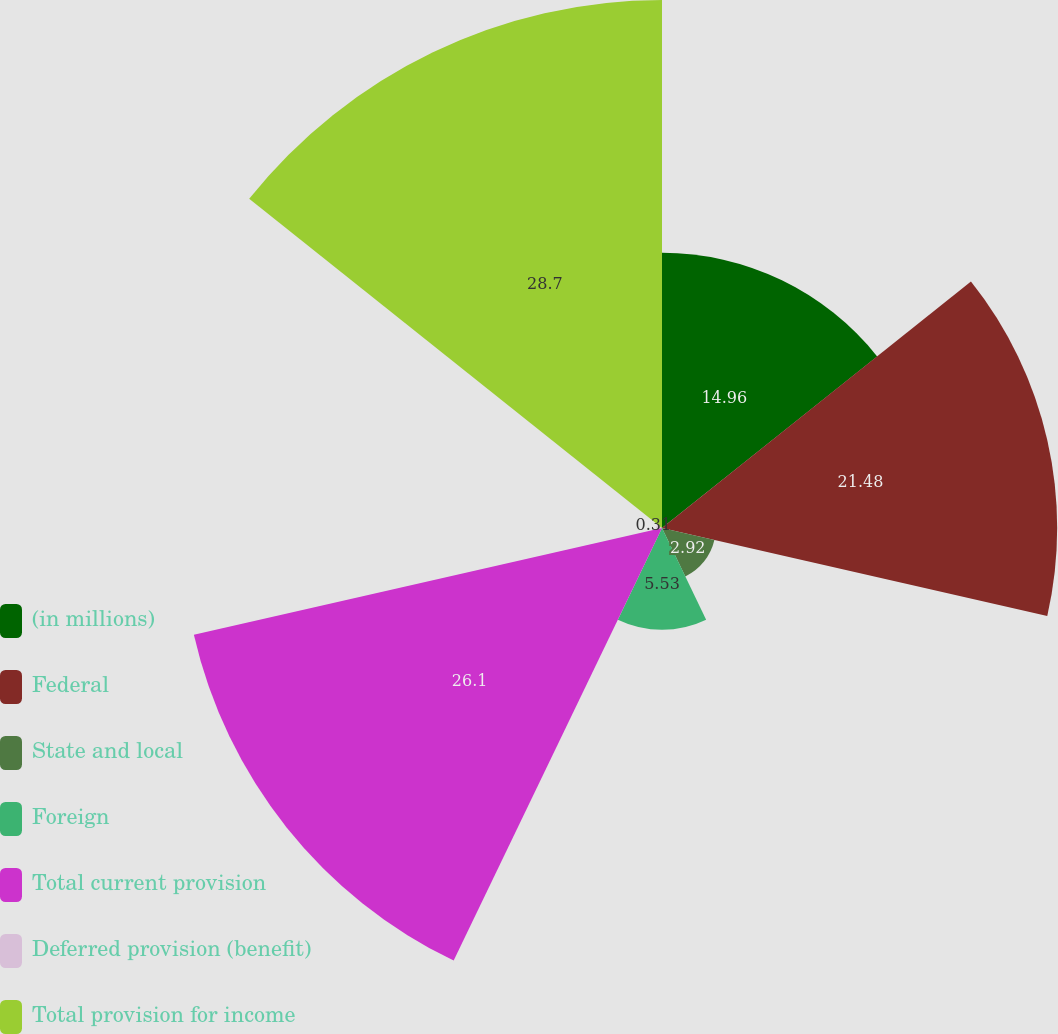Convert chart. <chart><loc_0><loc_0><loc_500><loc_500><pie_chart><fcel>(in millions)<fcel>Federal<fcel>State and local<fcel>Foreign<fcel>Total current provision<fcel>Deferred provision (benefit)<fcel>Total provision for income<nl><fcel>14.96%<fcel>21.48%<fcel>2.92%<fcel>5.53%<fcel>26.1%<fcel>0.31%<fcel>28.7%<nl></chart> 